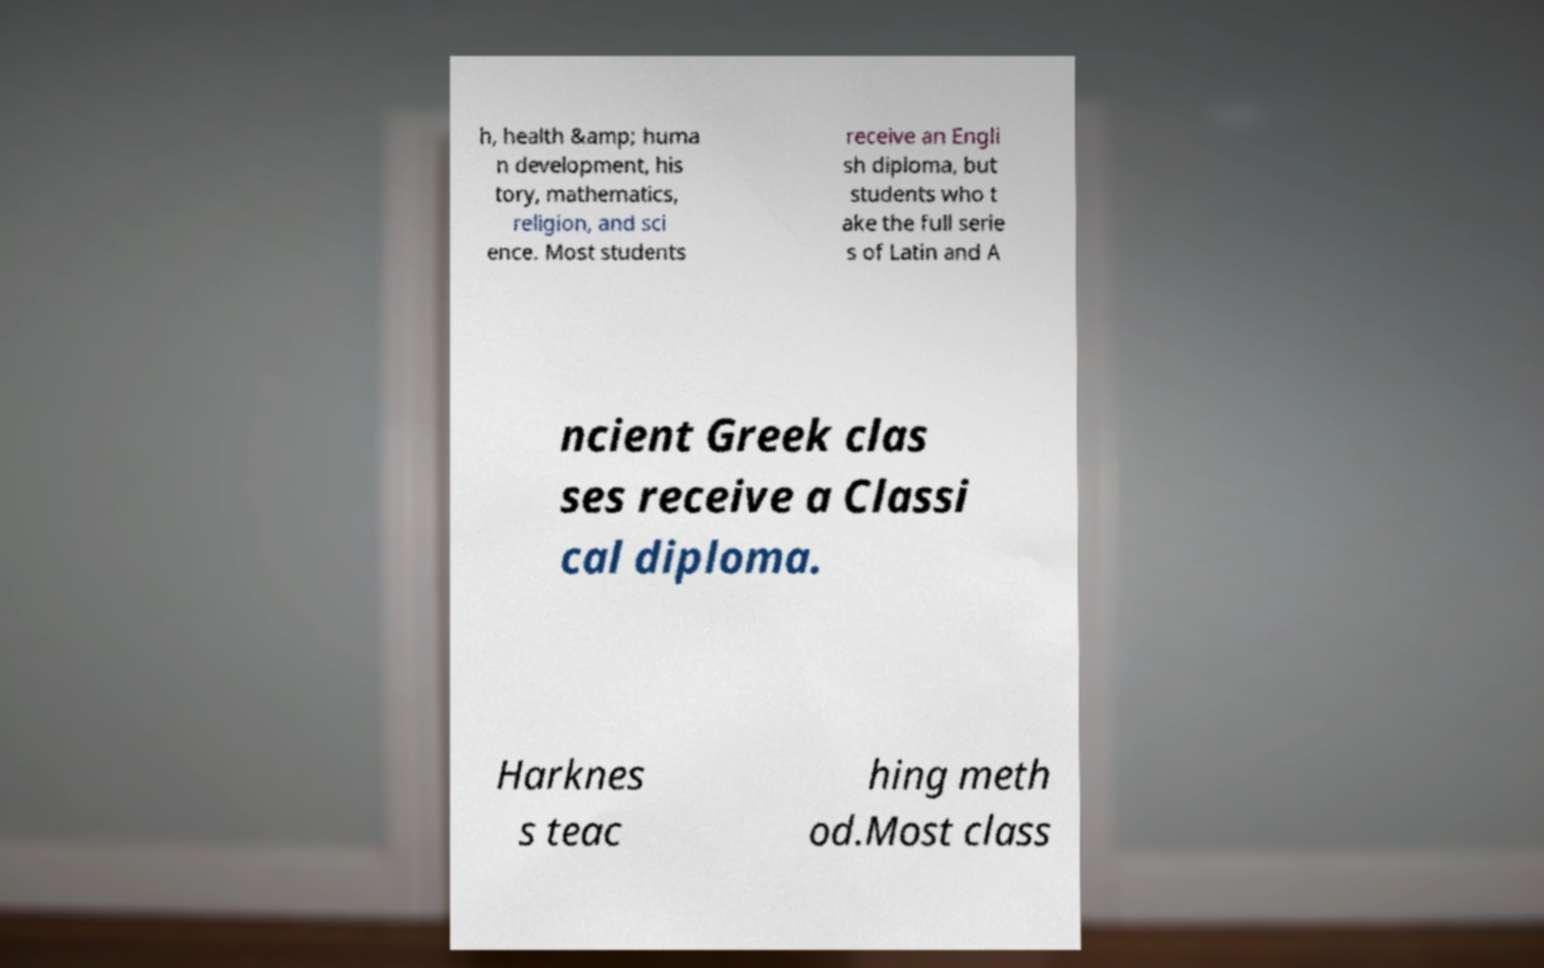Please identify and transcribe the text found in this image. h, health &amp; huma n development, his tory, mathematics, religion, and sci ence. Most students receive an Engli sh diploma, but students who t ake the full serie s of Latin and A ncient Greek clas ses receive a Classi cal diploma. Harknes s teac hing meth od.Most class 